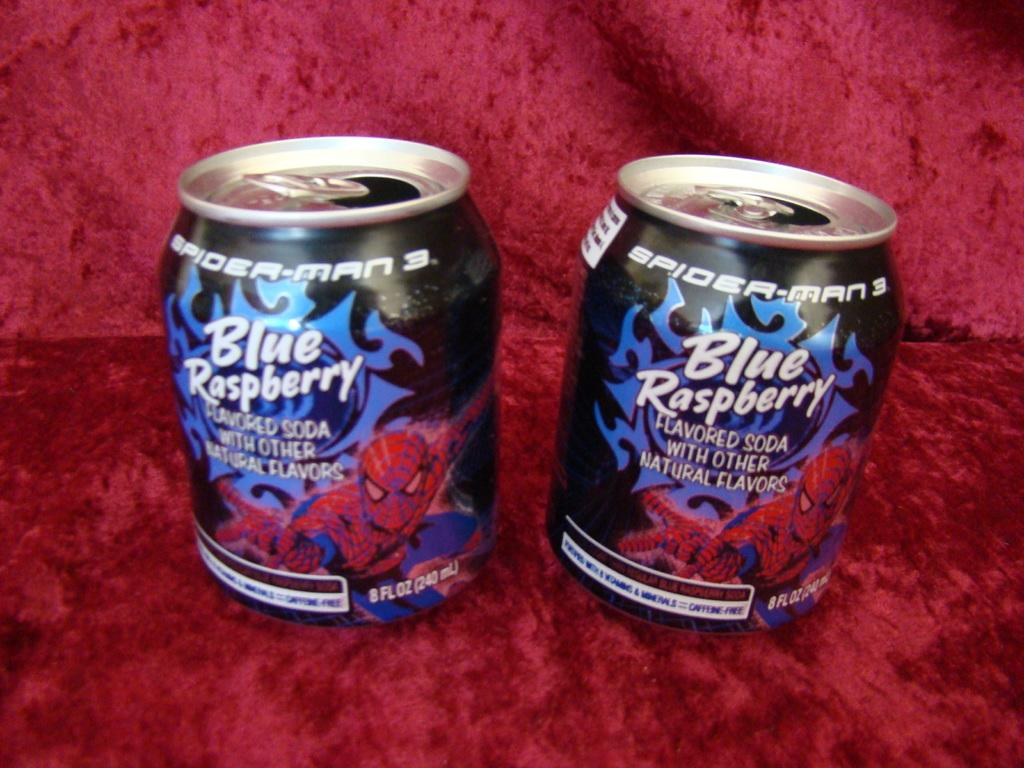<image>
Describe the image concisely. Two cans are next to each other are labeled blue raspberry. 